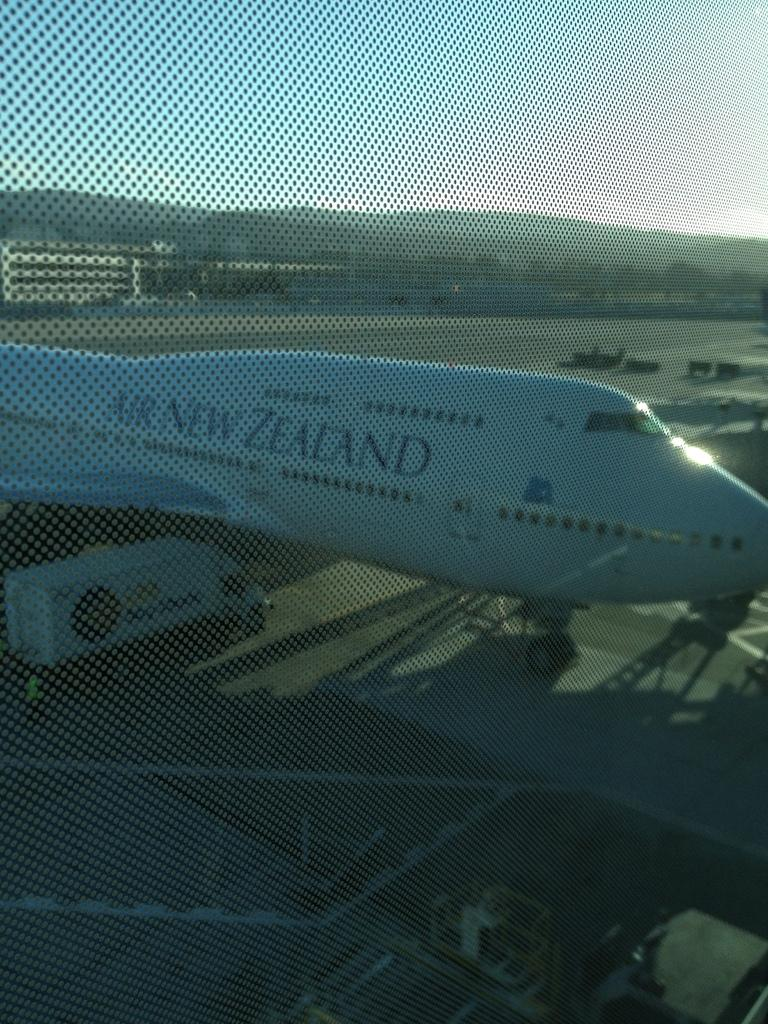What type of object is made of glass in the image? There is a glass object in the image, but its specific form is not mentioned. What is an unusual feature of the image? An airplane is visible on the road in the image, which is not a typical sight. What can be seen in the distance in the image? There are trees and the sky visible in the background of the image. How many chickens are running around the glass object in the image? There are no chickens present in the image. What is the title of the airplane on the road in the image? The image does not provide a title for the airplane. 